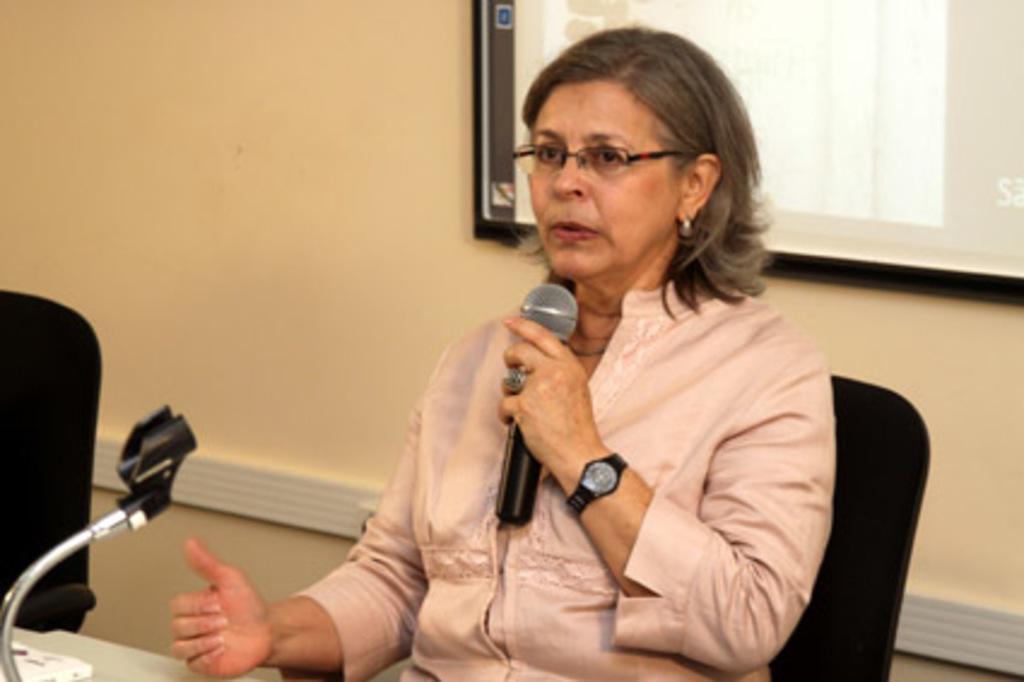Describe this image in one or two sentences. In the picture we can see a woman sitting on the chair and talking in the microphone holding it and she is sitting near the desk on it, we can see a microphone stand and some papers and beside her we can see another chair which is black in color and behind her we can see a wall with a glass window. 